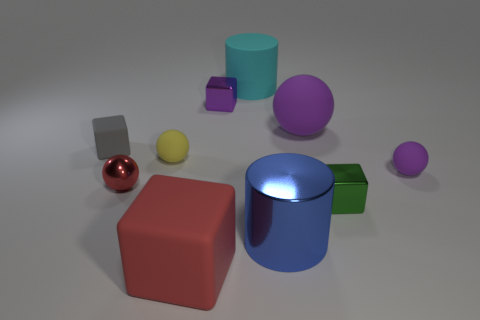Are there fewer tiny red metal spheres behind the large rubber cylinder than big cubes to the left of the large sphere?
Make the answer very short. Yes. There is a big block that is the same color as the shiny sphere; what is it made of?
Keep it short and to the point. Rubber. Is there any other thing that has the same shape as the large shiny thing?
Offer a terse response. Yes. There is a big cylinder in front of the green block; what material is it?
Give a very brief answer. Metal. Is there anything else that has the same size as the yellow thing?
Offer a very short reply. Yes. There is a matte cylinder; are there any tiny purple objects on the right side of it?
Provide a succinct answer. Yes. The small purple rubber thing is what shape?
Your answer should be very brief. Sphere. How many things are either things that are behind the red cube or tiny yellow balls?
Provide a short and direct response. 9. What number of other things are there of the same color as the large sphere?
Offer a very short reply. 2. Is the color of the large rubber ball the same as the small matte ball that is to the left of the large blue object?
Your answer should be compact. No. 